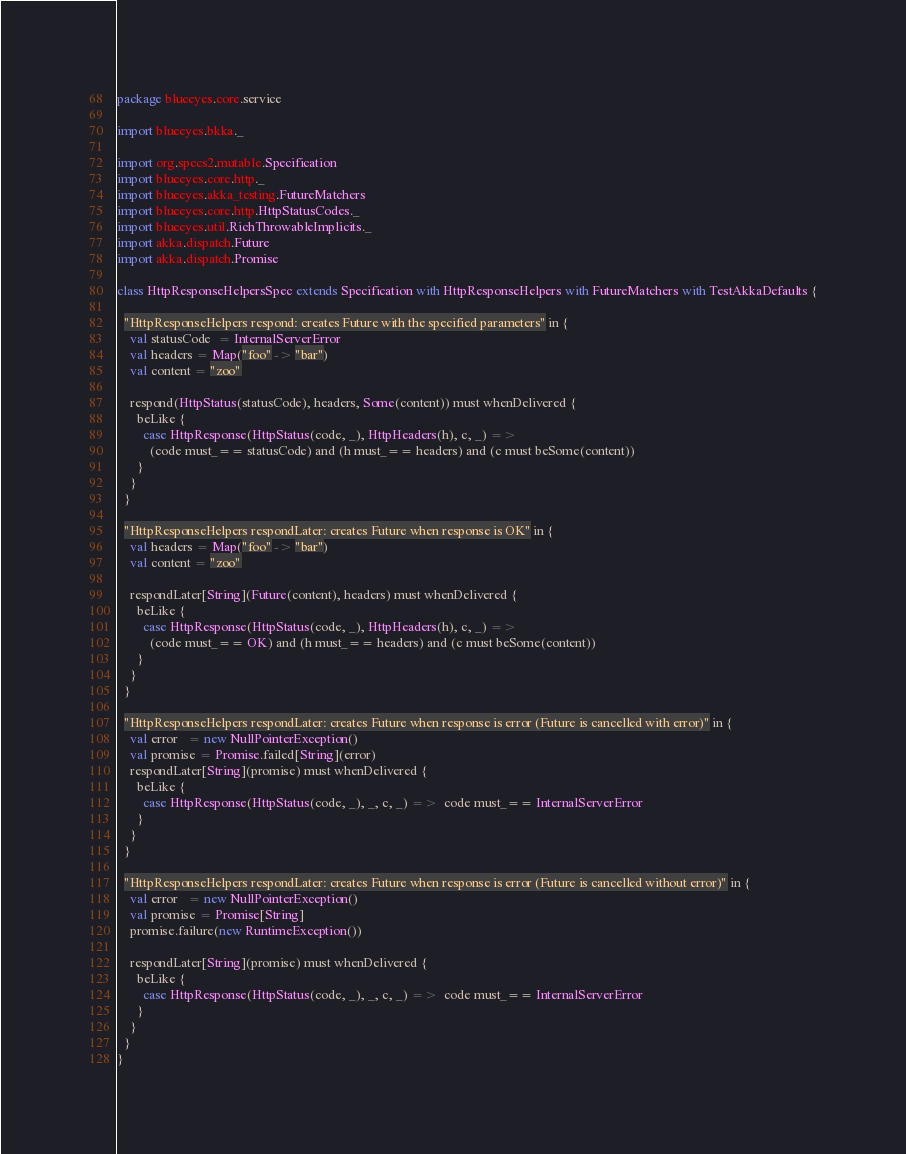<code> <loc_0><loc_0><loc_500><loc_500><_Scala_>package blueeyes.core.service

import blueeyes.bkka._

import org.specs2.mutable.Specification
import blueeyes.core.http._
import blueeyes.akka_testing.FutureMatchers
import blueeyes.core.http.HttpStatusCodes._
import blueeyes.util.RichThrowableImplicits._
import akka.dispatch.Future
import akka.dispatch.Promise

class HttpResponseHelpersSpec extends Specification with HttpResponseHelpers with FutureMatchers with TestAkkaDefaults {
  
  "HttpResponseHelpers respond: creates Future with the specified parameters" in {
    val statusCode  = InternalServerError
    val headers = Map("foo" -> "bar")
    val content = "zoo"

    respond(HttpStatus(statusCode), headers, Some(content)) must whenDelivered {
      beLike {
        case HttpResponse(HttpStatus(code, _), HttpHeaders(h), c, _) => 
          (code must_== statusCode) and (h must_== headers) and (c must beSome(content))
      }
    }
  }

  "HttpResponseHelpers respondLater: creates Future when response is OK" in {
    val headers = Map("foo" -> "bar")
    val content = "zoo"

    respondLater[String](Future(content), headers) must whenDelivered {
      beLike { 
        case HttpResponse(HttpStatus(code, _), HttpHeaders(h), c, _) => 
          (code must_== OK) and (h must_== headers) and (c must beSome(content))
      }
    }
  }

  "HttpResponseHelpers respondLater: creates Future when response is error (Future is cancelled with error)" in {
    val error   = new NullPointerException()
    val promise = Promise.failed[String](error)
    respondLater[String](promise) must whenDelivered {
      beLike {
        case HttpResponse(HttpStatus(code, _), _, c, _) =>  code must_== InternalServerError
      }
    }
  }

  "HttpResponseHelpers respondLater: creates Future when response is error (Future is cancelled without error)" in {
    val error   = new NullPointerException()
    val promise = Promise[String]
    promise.failure(new RuntimeException())

    respondLater[String](promise) must whenDelivered {
      beLike {
        case HttpResponse(HttpStatus(code, _), _, c, _) =>  code must_== InternalServerError
      }
    }
  }
}
</code> 